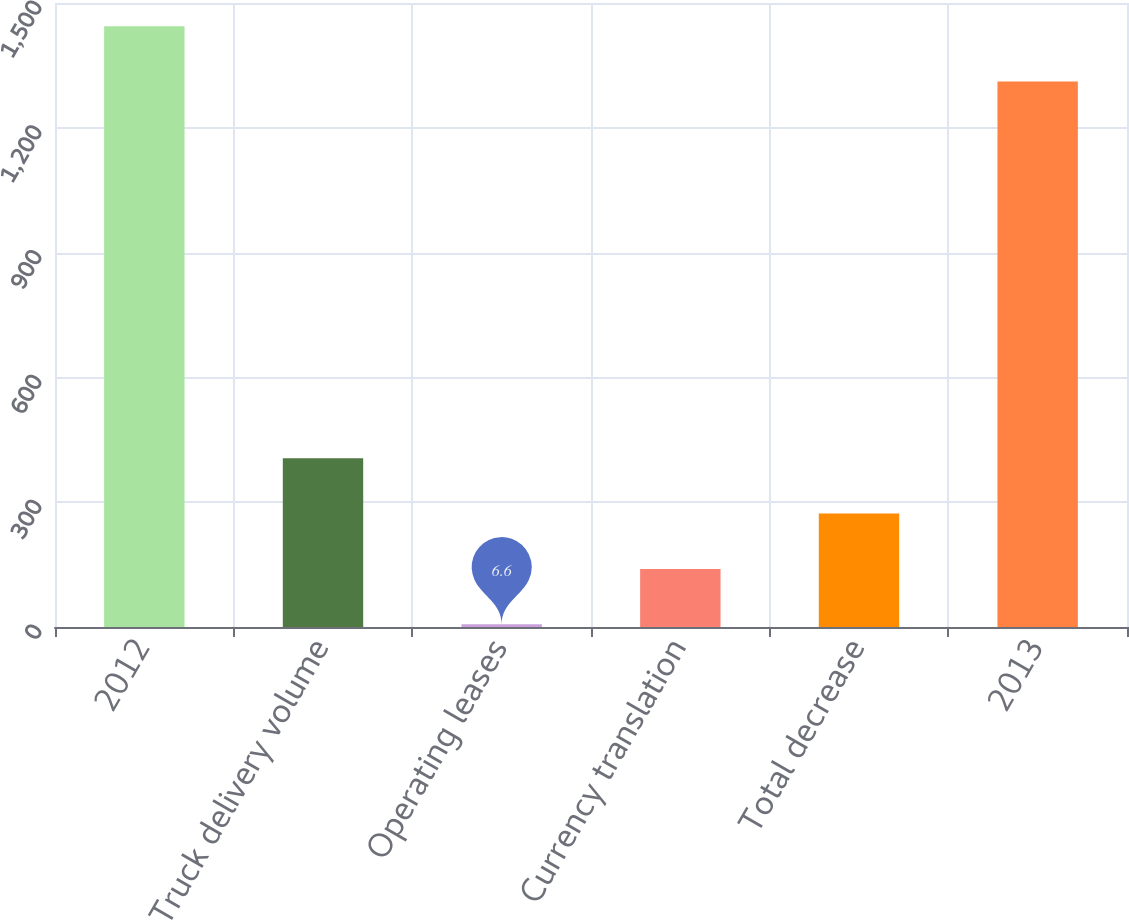Convert chart. <chart><loc_0><loc_0><loc_500><loc_500><bar_chart><fcel>2012<fcel>Truck delivery volume<fcel>Operating leases<fcel>Currency translation<fcel>Total decrease<fcel>2013<nl><fcel>1444.09<fcel>405.87<fcel>6.6<fcel>139.69<fcel>272.78<fcel>1311<nl></chart> 